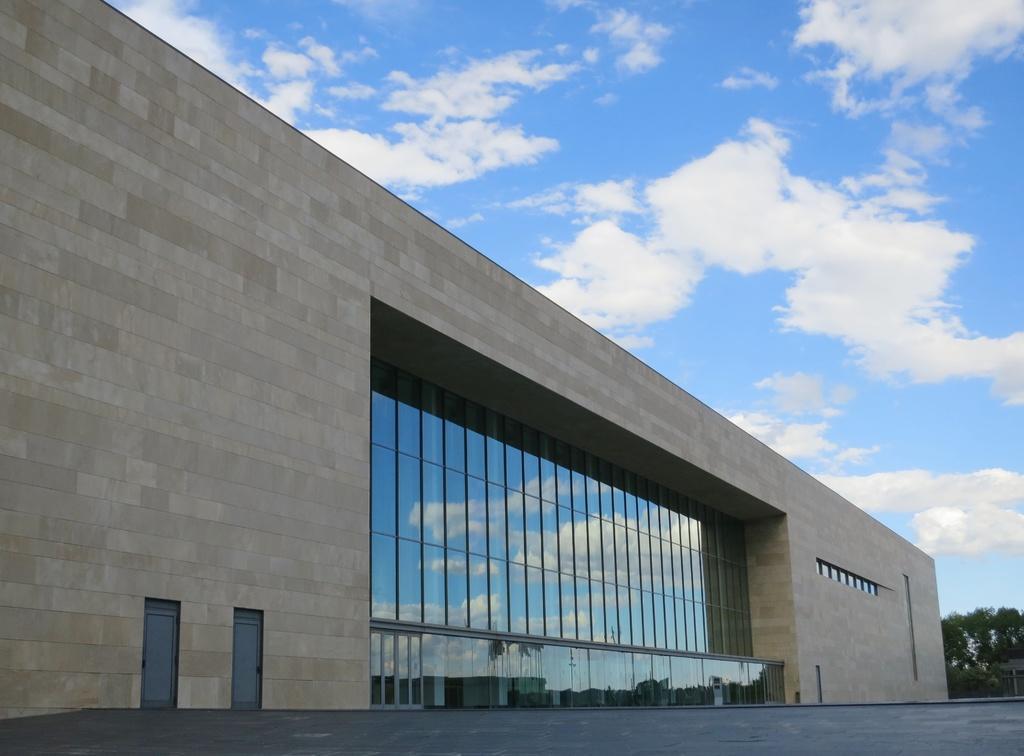How would you summarize this image in a sentence or two? In this picture I can see a building and couple of doors and I can see trees and a blue cloudy sky. 